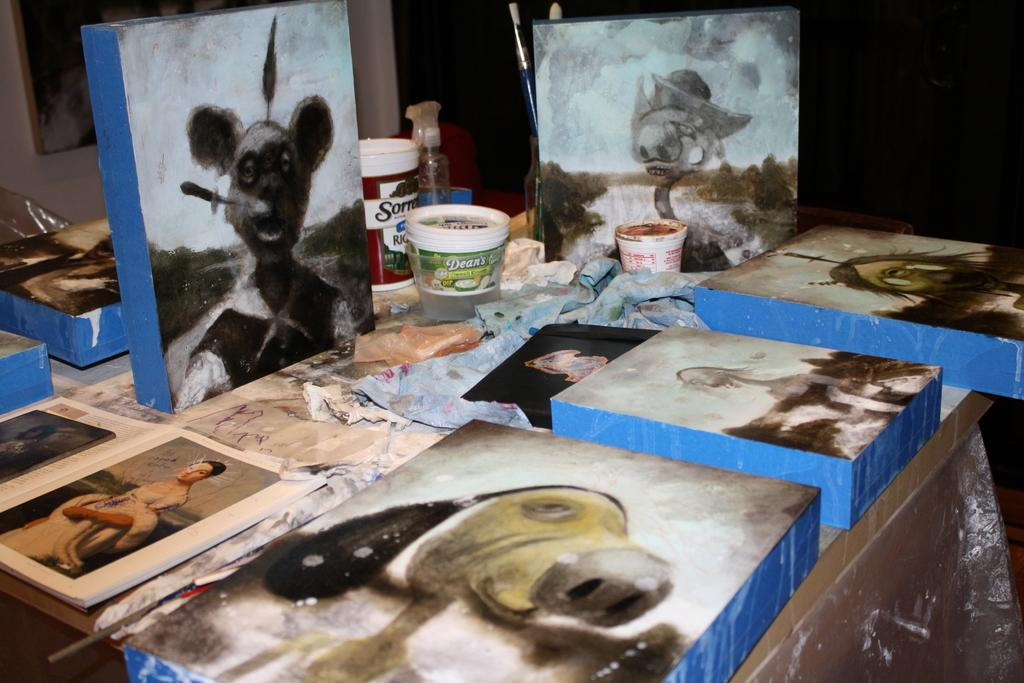What is the main subject in the center of the image? There are books in the center of the image. What else can be seen on the table in the image? There are objects and containers on the table. Is there a table in the image? Yes, the table is in the image. What can be seen in the background of the image? There is a photo frame and a wall in the background of the image. What type of flower is growing on the table in the image? There are no flowers present on the table in the image. 